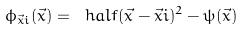Convert formula to latex. <formula><loc_0><loc_0><loc_500><loc_500>\phi _ { \vec { x } i } ( \vec { x } ) = \ h a l f ( \vec { x } - \vec { x } i ) ^ { 2 } - \psi ( \vec { x } )</formula> 